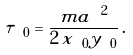Convert formula to latex. <formula><loc_0><loc_0><loc_500><loc_500>\tau _ { \ 0 } = \frac { m a ^ { \ 2 } } { 2 \, x _ { \ 0 } y _ { \ 0 } } \, .</formula> 